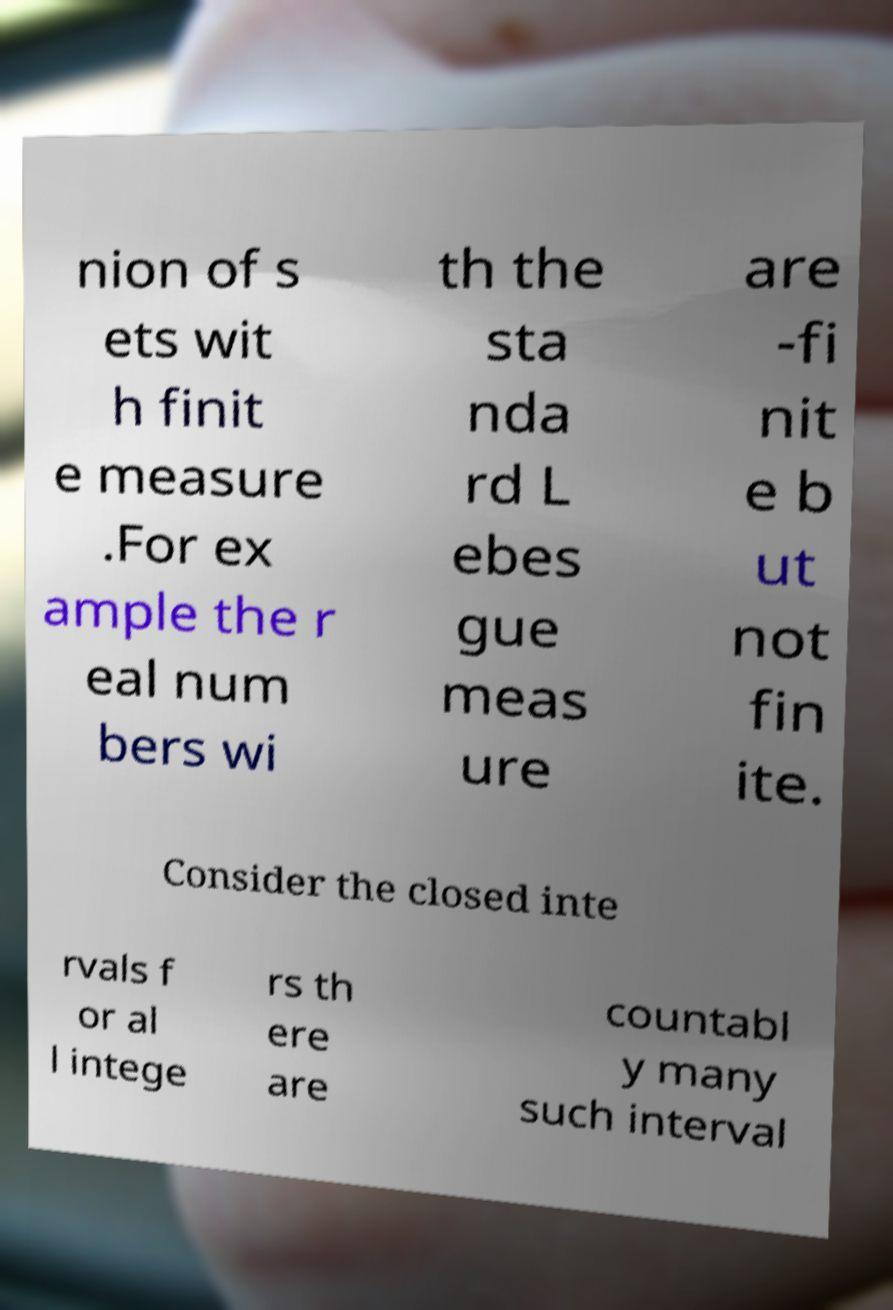What messages or text are displayed in this image? I need them in a readable, typed format. nion of s ets wit h finit e measure .For ex ample the r eal num bers wi th the sta nda rd L ebes gue meas ure are -fi nit e b ut not fin ite. Consider the closed inte rvals f or al l intege rs th ere are countabl y many such interval 